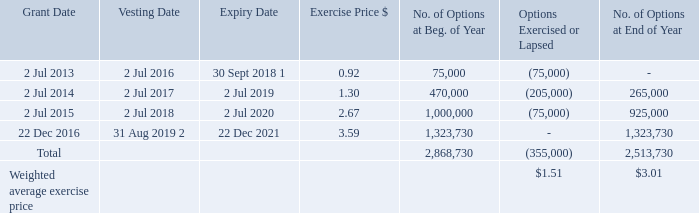16. SHARE-BASED PAYMENTS continued
c. Employee Share Option Plan
The Employee Share Option Plan (the Option Plan) was approved by shareholders at the Company’s AGM on 9 November 2001 and reaffirmed at the AGM on 24 November 2011.The Employee Share Option Plan (the Option Plan) was approved by shareholders at the Company’s AGM on 9 November 2001 and reaffirmed at the AGM on 24 November 2011. Under the Option Plan, awards are made to eligible executives and other management personnel who have an impact on the Group’s performance. Option Plan awards are delivered in the form of options over shares, which vest over a period of three years subject to meeting performance measures and continuous employment with the Company. Each option is to subscribe for one ordinary share when the option is exercised and, when issued, the shares will rank equally with other shares.
Unless the terms on which an option was offered specified otherwise, an option may be exercised at any time after the vesting date on satisfaction of the relevant performance criteria.
Options issued under the Employee Share Option Plan are valued on the same basis as those issued to KMP, which is described in Note 16(d).
There were no new options issued under the Option Plan during the 30 June 2019 and 30 June 2018 financial years, as the Option Plan was replaced with the Rights Plan as described in Note 16(b).
Movement of options during the year ended 30 June 2019:
1. The original expiry date for this tranche of options was 2 July 2018. However, due to extraordinary circumstances, the remaining 75,000 options could not be exercised during the prior financial year. Therefore, the Board had exercised its discretion during the year to extend the expiry date for the remaining options to 30 September 2018.
2. Options associated with an EPS hurdle are not expected to vest on 31 August 2019 as the minimum performance target will not be met. Options associated with a TSR hurdle will vest on 31 August 2019 in accordance with accounting standards. However, because the minimum target was not met, these options will be restricted and unexercisable. Refer to Section 3b) of the audited Remuneration Report for further details.
How many options granted on 2 July 2015 were exercised or lapsed? 75,000. Why were there no new options issued under the Option Plan during the 30 June 2019 and 30 June 2018 financial years? As the option plan was replaced with the rights plan. What was the exercise price for options granted on 2 July 2014? 1.30. What was the total percentage change in number of options at beginning of the year for options granted between 2013 and 2016?
Answer scale should be: percent. (1,323,730 - 75,000) / 75,000 
Answer: 1664.97. What was the total weighted exercise cost for all options that were exercised or lapsed? 355,000 * $1.51 
Answer: 536050. What was the total percentage change in exercise price for options granted between 2013 and 2016?
Answer scale should be: percent. (3.59 - 0.92) / 0.92 
Answer: 290.22. 